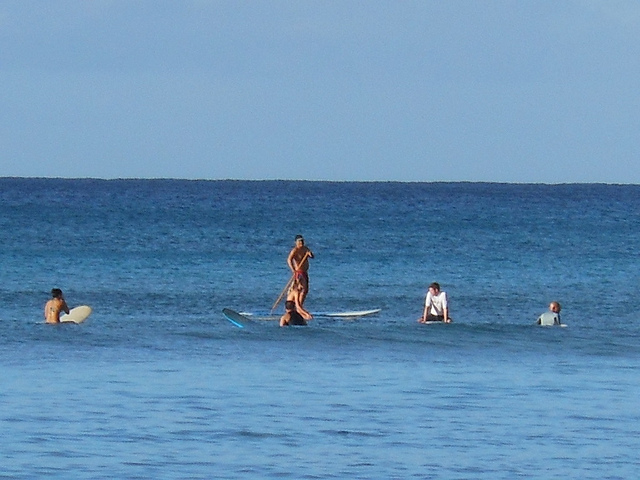What is the man who is standing doing?
A. rowing
B. eating
C. jumping
D. waving
Answer with the option's letter from the given choices directly. The man who is standing appears to be engaged in an activity related to water sports, most likely stand-up paddleboarding, which involves standing on a board and using a paddle to propel oneself through the water. None of the provided options accurately describe this activity. A correct answer reflecting the image's content would be 'E. paddleboarding,' if that had been an available choice. 